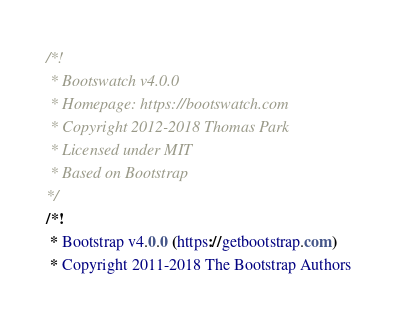Convert code to text. <code><loc_0><loc_0><loc_500><loc_500><_CSS_>/*!
 * Bootswatch v4.0.0
 * Homepage: https://bootswatch.com
 * Copyright 2012-2018 Thomas Park
 * Licensed under MIT
 * Based on Bootstrap
*/
/*!
 * Bootstrap v4.0.0 (https://getbootstrap.com)
 * Copyright 2011-2018 The Bootstrap Authors</code> 